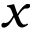<formula> <loc_0><loc_0><loc_500><loc_500>x</formula> 